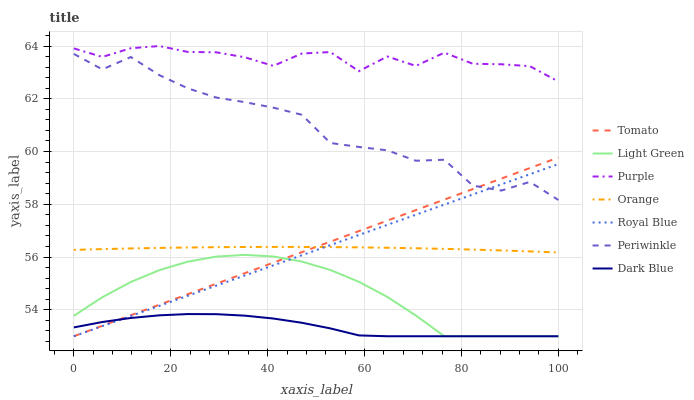Does Dark Blue have the minimum area under the curve?
Answer yes or no. Yes. Does Purple have the maximum area under the curve?
Answer yes or no. Yes. Does Purple have the minimum area under the curve?
Answer yes or no. No. Does Dark Blue have the maximum area under the curve?
Answer yes or no. No. Is Tomato the smoothest?
Answer yes or no. Yes. Is Purple the roughest?
Answer yes or no. Yes. Is Dark Blue the smoothest?
Answer yes or no. No. Is Dark Blue the roughest?
Answer yes or no. No. Does Tomato have the lowest value?
Answer yes or no. Yes. Does Purple have the lowest value?
Answer yes or no. No. Does Purple have the highest value?
Answer yes or no. Yes. Does Dark Blue have the highest value?
Answer yes or no. No. Is Royal Blue less than Purple?
Answer yes or no. Yes. Is Purple greater than Orange?
Answer yes or no. Yes. Does Royal Blue intersect Light Green?
Answer yes or no. Yes. Is Royal Blue less than Light Green?
Answer yes or no. No. Is Royal Blue greater than Light Green?
Answer yes or no. No. Does Royal Blue intersect Purple?
Answer yes or no. No. 